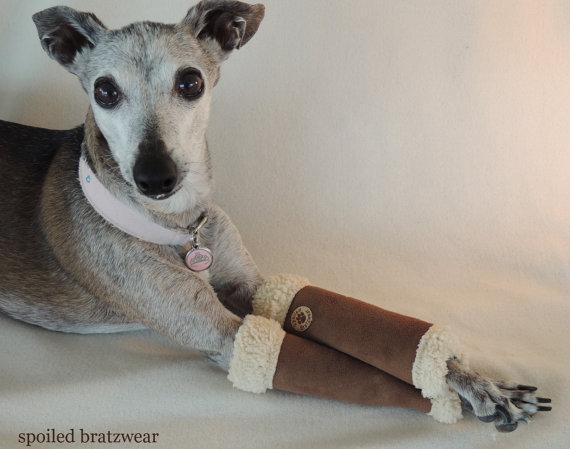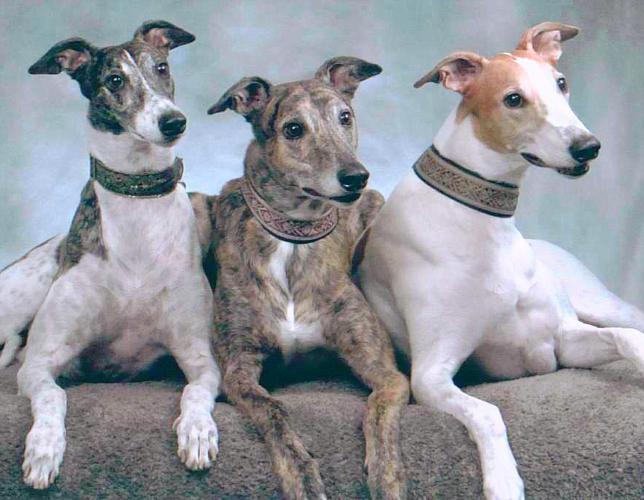The first image is the image on the left, the second image is the image on the right. For the images displayed, is the sentence "Three dogs are posing together in one of the images." factually correct? Answer yes or no. Yes. 